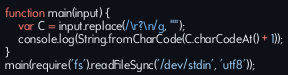Convert code to text. <code><loc_0><loc_0><loc_500><loc_500><_JavaScript_>function main(input) {
    var C = input.replace(/\r?\n/g, "");
    console.log(String.fromCharCode(C.charCodeAt() + 1));
}
main(require('fs').readFileSync('/dev/stdin', 'utf8'));</code> 